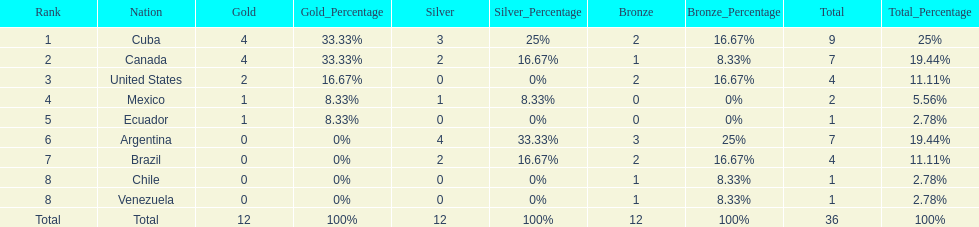Would you mind parsing the complete table? {'header': ['Rank', 'Nation', 'Gold', 'Gold_Percentage', 'Silver', 'Silver_Percentage', 'Bronze', 'Bronze_Percentage', 'Total', 'Total_Percentage'], 'rows': [['1', 'Cuba', '4', '33.33%', '3', '25%', '2', '16.67%', '9', '25%'], ['2', 'Canada', '4', '33.33%', '2', '16.67%', '1', '8.33%', '7', '19.44%'], ['3', 'United States', '2', '16.67%', '0', '0%', '2', '16.67%', '4', '11.11%'], ['4', 'Mexico', '1', '8.33%', '1', '8.33%', '0', '0%', '2', '5.56%'], ['5', 'Ecuador', '1', '8.33%', '0', '0%', '0', '0%', '1', '2.78%'], ['6', 'Argentina', '0', '0%', '4', '33.33%', '3', '25%', '7', '19.44%'], ['7', 'Brazil', '0', '0%', '2', '16.67%', '2', '16.67%', '4', '11.11%'], ['8', 'Chile', '0', '0%', '0', '0%', '1', '8.33%', '1', '2.78%'], ['8', 'Venezuela', '0', '0%', '0', '0%', '1', '8.33%', '1', '2.78%'], ['Total', 'Total', '12', '100%', '12', '100%', '12', '100%', '36', '100%']]} Who had more silver medals, cuba or brazil? Cuba. 